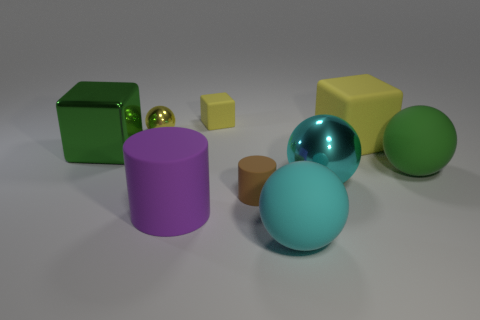Subtract all green matte balls. How many balls are left? 3 Subtract all gray balls. How many yellow blocks are left? 2 Subtract all yellow spheres. How many spheres are left? 3 Add 1 big cyan rubber spheres. How many objects exist? 10 Subtract all purple blocks. Subtract all brown cylinders. How many blocks are left? 3 Subtract all cubes. How many objects are left? 6 Subtract all tiny purple shiny cylinders. Subtract all yellow rubber objects. How many objects are left? 7 Add 5 large purple cylinders. How many large purple cylinders are left? 6 Add 9 tiny cyan shiny blocks. How many tiny cyan shiny blocks exist? 9 Subtract 0 purple spheres. How many objects are left? 9 